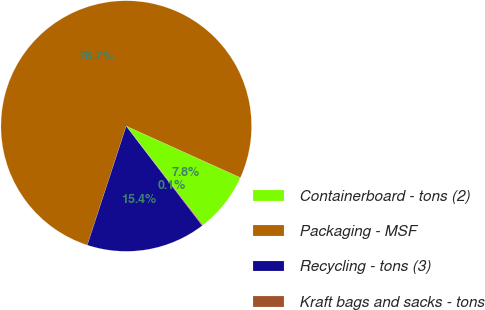Convert chart to OTSL. <chart><loc_0><loc_0><loc_500><loc_500><pie_chart><fcel>Containerboard - tons (2)<fcel>Packaging - MSF<fcel>Recycling - tons (3)<fcel>Kraft bags and sacks - tons<nl><fcel>7.76%<fcel>76.73%<fcel>15.42%<fcel>0.1%<nl></chart> 